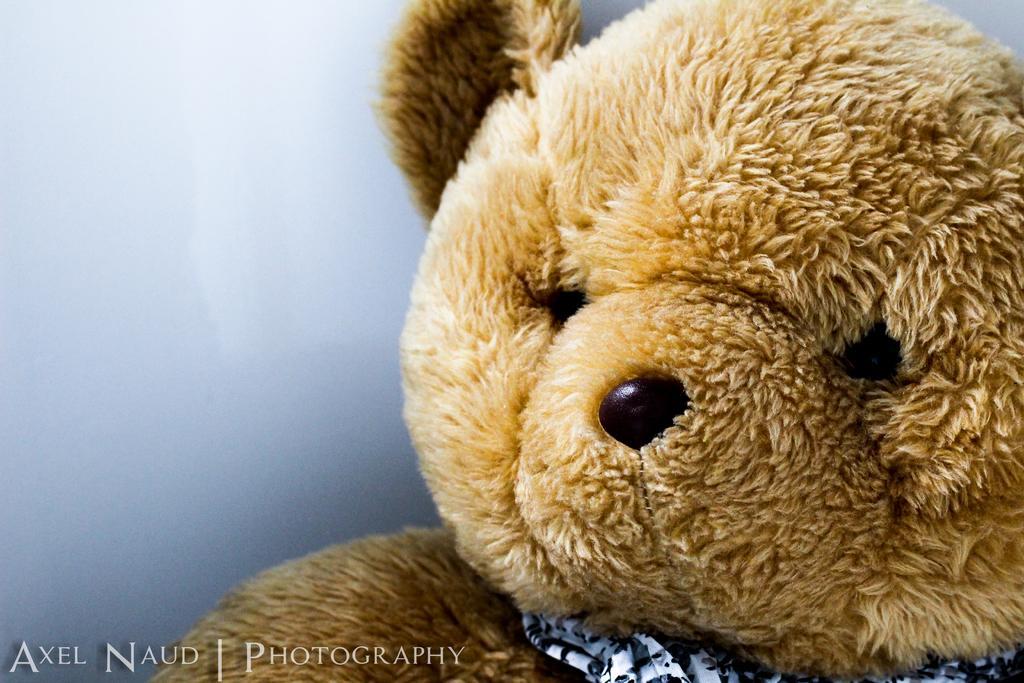Could you give a brief overview of what you see in this image? In this image I can see a teddy bear, text and ash color background. This image is taken may be in a studio. 